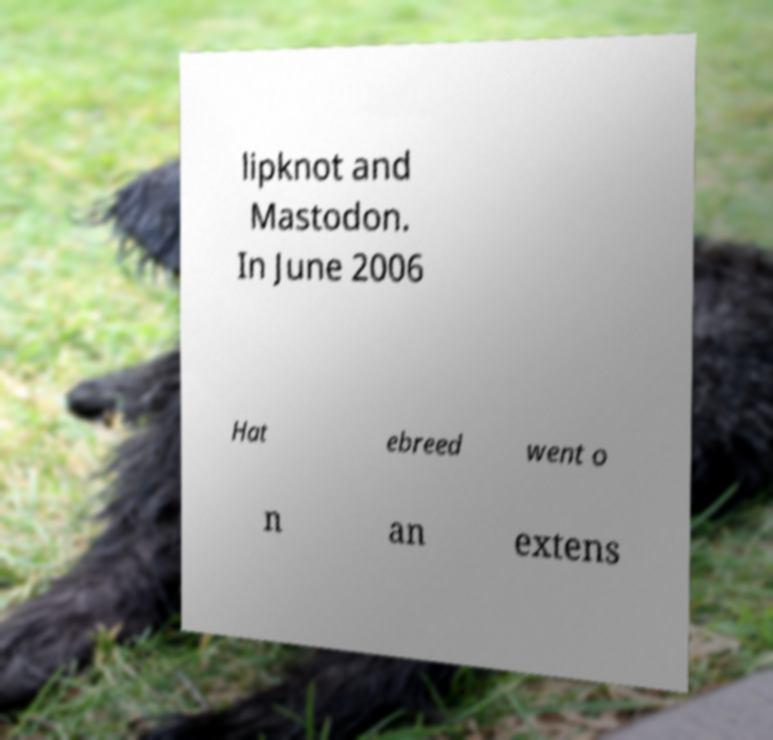For documentation purposes, I need the text within this image transcribed. Could you provide that? lipknot and Mastodon. In June 2006 Hat ebreed went o n an extens 